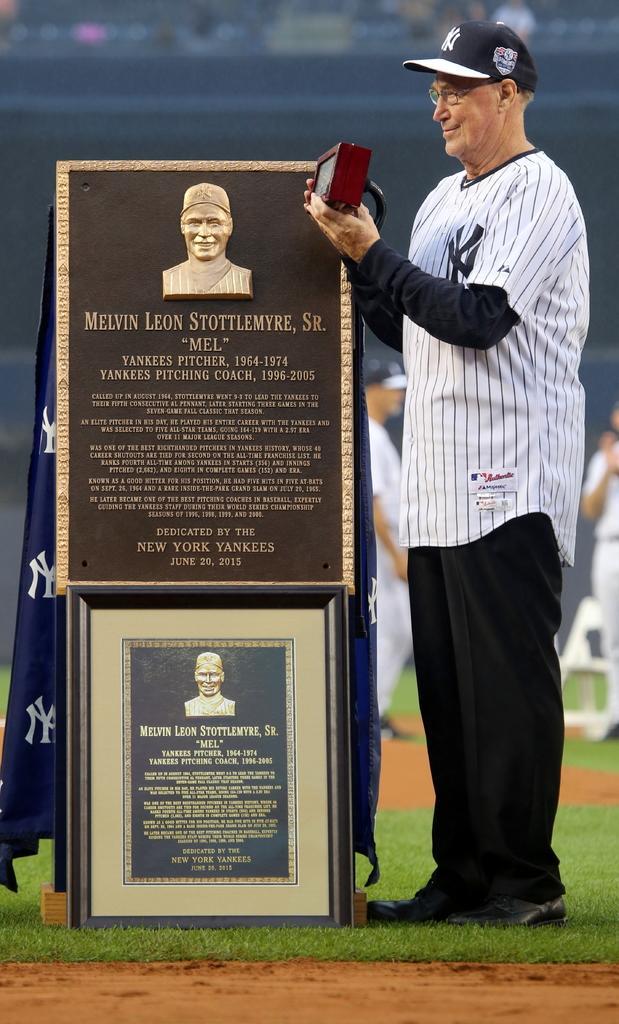In one or two sentences, can you explain what this image depicts? In this image on the right there is a man, he wears a t shirt, trouser, shoes and cap, he is holding a box. In the middle there is a photo frame, cloth and stone on that there is text. In the background there are some people, grassland. 